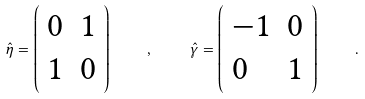Convert formula to latex. <formula><loc_0><loc_0><loc_500><loc_500>\hat { \eta } = \left ( \begin{array} { l l } { 0 } & { 1 } \\ { 1 } & { 0 } \end{array} \right ) \quad , \quad \hat { \gamma } = \left ( \begin{array} { l l } { - 1 } & { 0 } \\ { 0 } & { 1 } \end{array} \right ) \quad .</formula> 